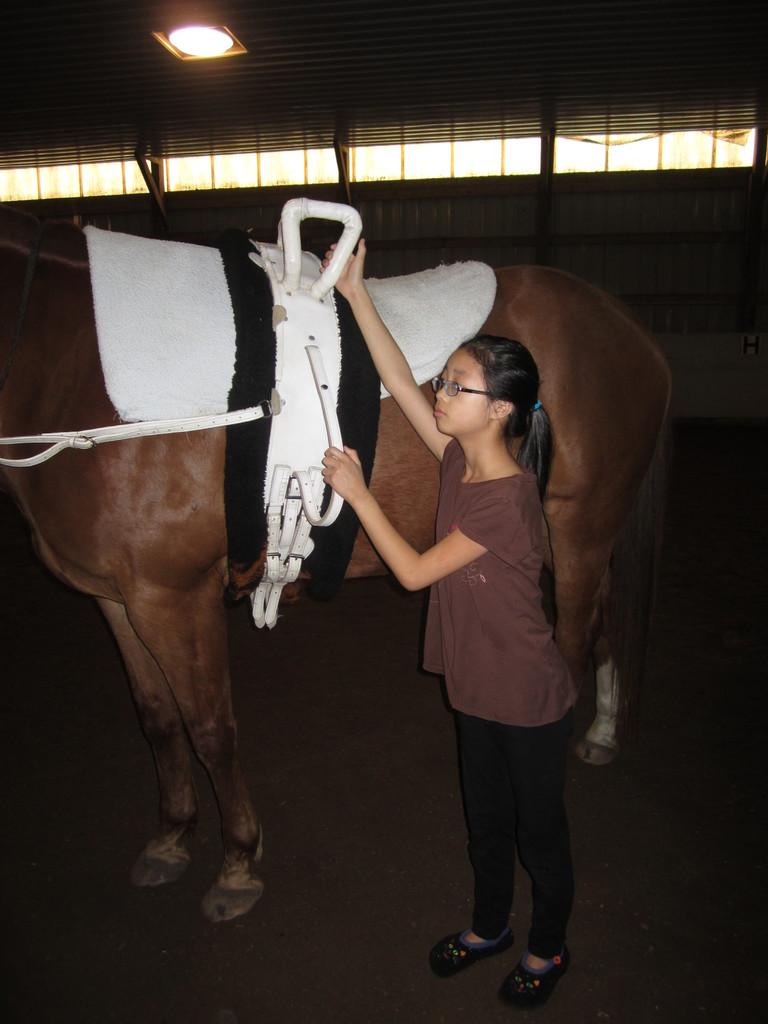Who is the main subject in the image? There is a girl in the image. Where is the girl located in the image? The girl is on the right side of the image. What is the girl doing in the image? The girl is putting her hand on a horse. What is the position of the horse in the image? The horse is in the center of the image. What structure is visible in the image? There is a roof in the image. What is on the roof in the image? There is a lighting arrangement on the roof. How many bears are visible on the roof in the image? There are no bears visible on the roof in the image. What type of boundary is present in the image? There is no boundary mentioned or visible in the image. 